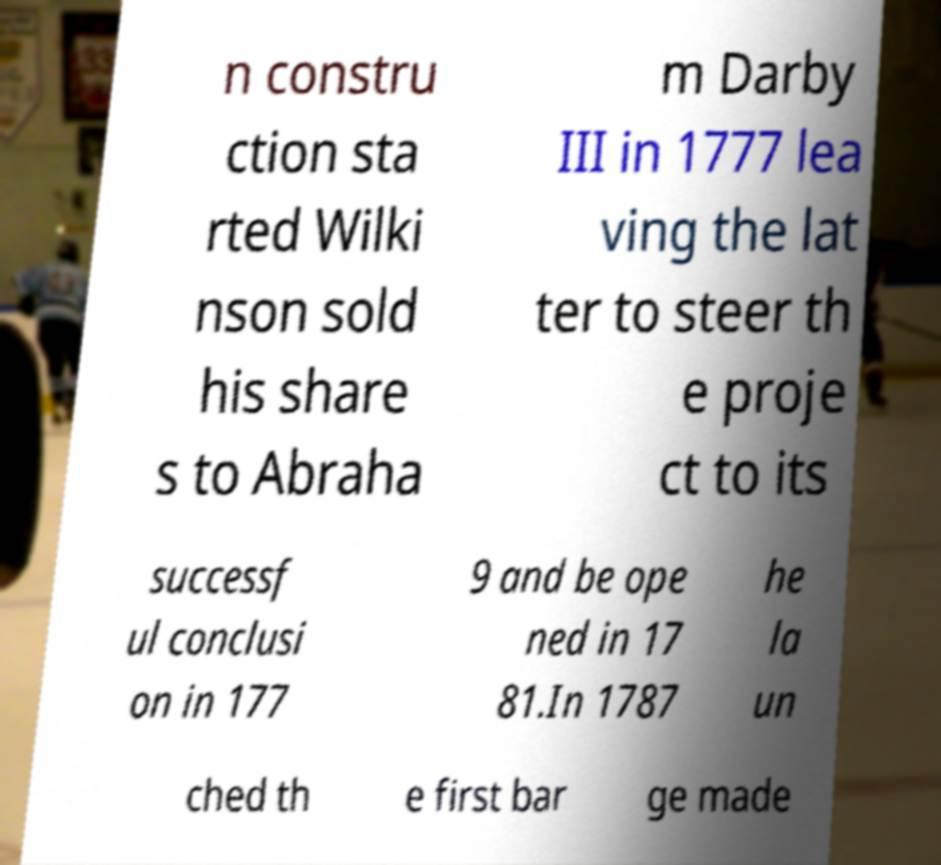Please identify and transcribe the text found in this image. n constru ction sta rted Wilki nson sold his share s to Abraha m Darby III in 1777 lea ving the lat ter to steer th e proje ct to its successf ul conclusi on in 177 9 and be ope ned in 17 81.In 1787 he la un ched th e first bar ge made 